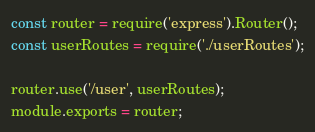Convert code to text. <code><loc_0><loc_0><loc_500><loc_500><_JavaScript_>const router = require('express').Router();
const userRoutes = require('./userRoutes');

router.use('/user', userRoutes);
module.exports = router;
</code> 